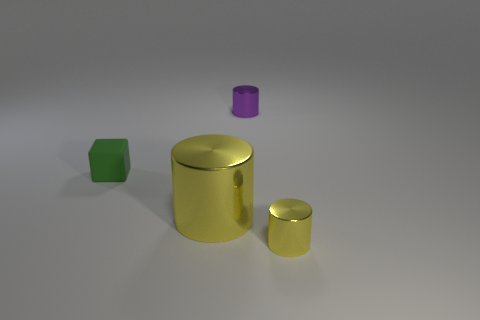Are there an equal number of big cylinders that are behind the small purple metallic thing and metal cylinders?
Offer a terse response. No. How many other objects are the same material as the tiny yellow thing?
Offer a very short reply. 2. There is a shiny thing that is behind the small green cube; is it the same size as the yellow metallic cylinder that is on the left side of the small yellow cylinder?
Your response must be concise. No. What number of objects are either objects that are on the left side of the big yellow metallic cylinder or cylinders behind the tiny green rubber thing?
Offer a very short reply. 2. Is there anything else that has the same shape as the green object?
Your answer should be compact. No. Does the small object that is in front of the green object have the same color as the big thing behind the small yellow object?
Keep it short and to the point. Yes. What number of metal things are either yellow cylinders or tiny cyan things?
Offer a terse response. 2. There is a thing that is left of the big yellow shiny cylinder that is in front of the tiny green cube; what is its shape?
Your response must be concise. Cube. Are the tiny cylinder that is to the left of the tiny yellow object and the small thing that is to the left of the big yellow shiny thing made of the same material?
Keep it short and to the point. No. What number of tiny yellow objects are in front of the tiny yellow metallic thing that is in front of the big cylinder?
Give a very brief answer. 0. 